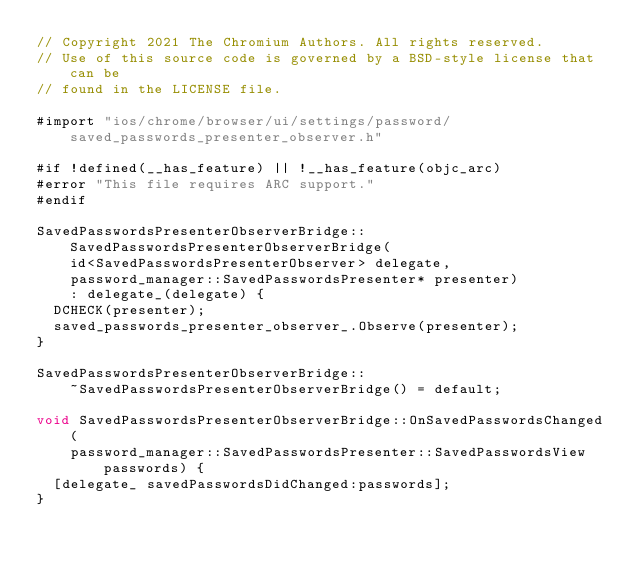Convert code to text. <code><loc_0><loc_0><loc_500><loc_500><_ObjectiveC_>// Copyright 2021 The Chromium Authors. All rights reserved.
// Use of this source code is governed by a BSD-style license that can be
// found in the LICENSE file.

#import "ios/chrome/browser/ui/settings/password/saved_passwords_presenter_observer.h"

#if !defined(__has_feature) || !__has_feature(objc_arc)
#error "This file requires ARC support."
#endif

SavedPasswordsPresenterObserverBridge::SavedPasswordsPresenterObserverBridge(
    id<SavedPasswordsPresenterObserver> delegate,
    password_manager::SavedPasswordsPresenter* presenter)
    : delegate_(delegate) {
  DCHECK(presenter);
  saved_passwords_presenter_observer_.Observe(presenter);
}

SavedPasswordsPresenterObserverBridge::
    ~SavedPasswordsPresenterObserverBridge() = default;

void SavedPasswordsPresenterObserverBridge::OnSavedPasswordsChanged(
    password_manager::SavedPasswordsPresenter::SavedPasswordsView passwords) {
  [delegate_ savedPasswordsDidChanged:passwords];
}
</code> 